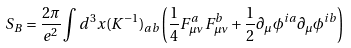<formula> <loc_0><loc_0><loc_500><loc_500>S _ { B } = \frac { 2 \pi } { e ^ { 2 } } \int d ^ { 3 } x ( K ^ { - 1 } ) _ { a b } \left ( \frac { 1 } { 4 } F ^ { a } _ { \mu \nu } F ^ { b } _ { \mu \nu } + \frac { 1 } { 2 } \partial _ { \mu } \phi ^ { i a } \partial _ { \mu } \phi ^ { i b } \right )</formula> 